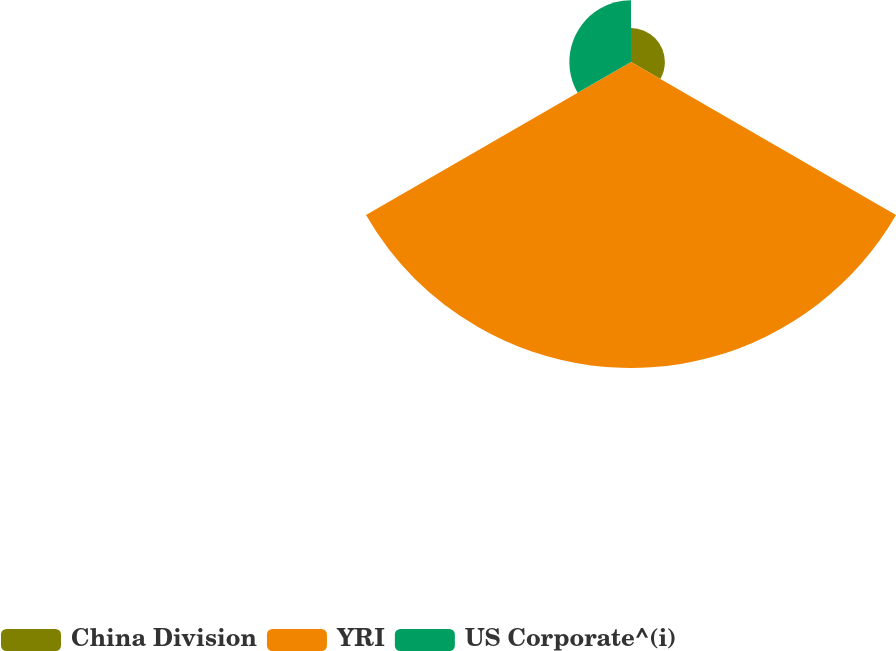Convert chart. <chart><loc_0><loc_0><loc_500><loc_500><pie_chart><fcel>China Division<fcel>YRI<fcel>US Corporate^(i)<nl><fcel>8.44%<fcel>76.21%<fcel>15.35%<nl></chart> 